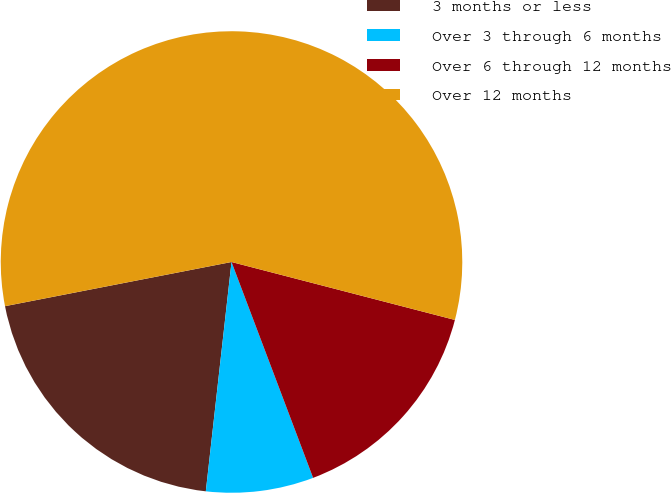Convert chart to OTSL. <chart><loc_0><loc_0><loc_500><loc_500><pie_chart><fcel>3 months or less<fcel>Over 3 through 6 months<fcel>Over 6 through 12 months<fcel>Over 12 months<nl><fcel>20.16%<fcel>7.53%<fcel>15.21%<fcel>57.11%<nl></chart> 